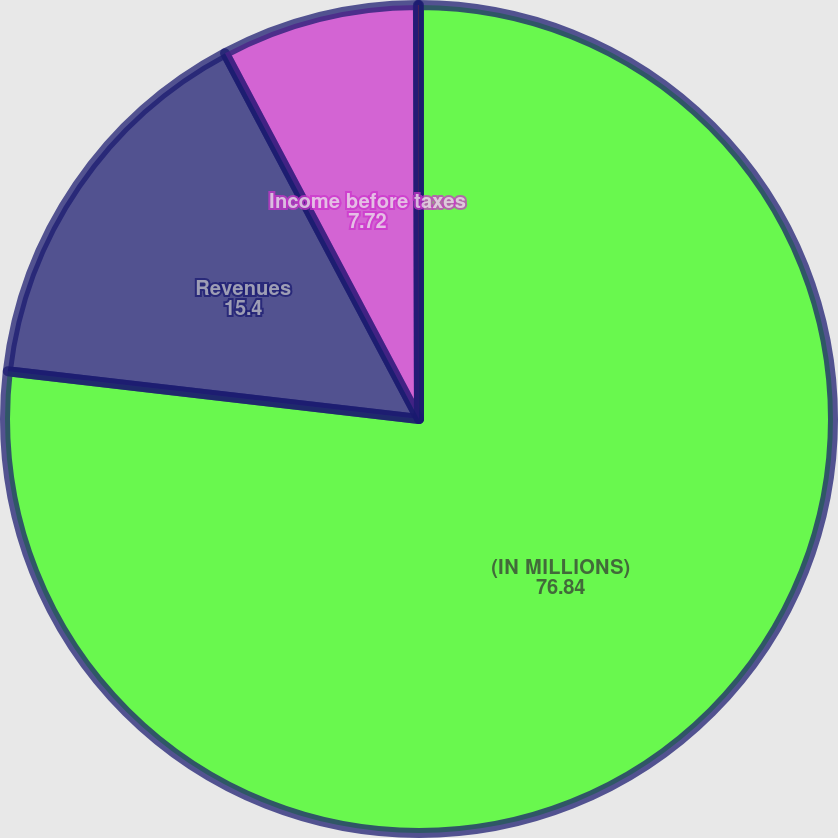Convert chart. <chart><loc_0><loc_0><loc_500><loc_500><pie_chart><fcel>(IN MILLIONS)<fcel>Revenues<fcel>Income before taxes<fcel>Gain on disposals net of tax<nl><fcel>76.84%<fcel>15.4%<fcel>7.72%<fcel>0.04%<nl></chart> 